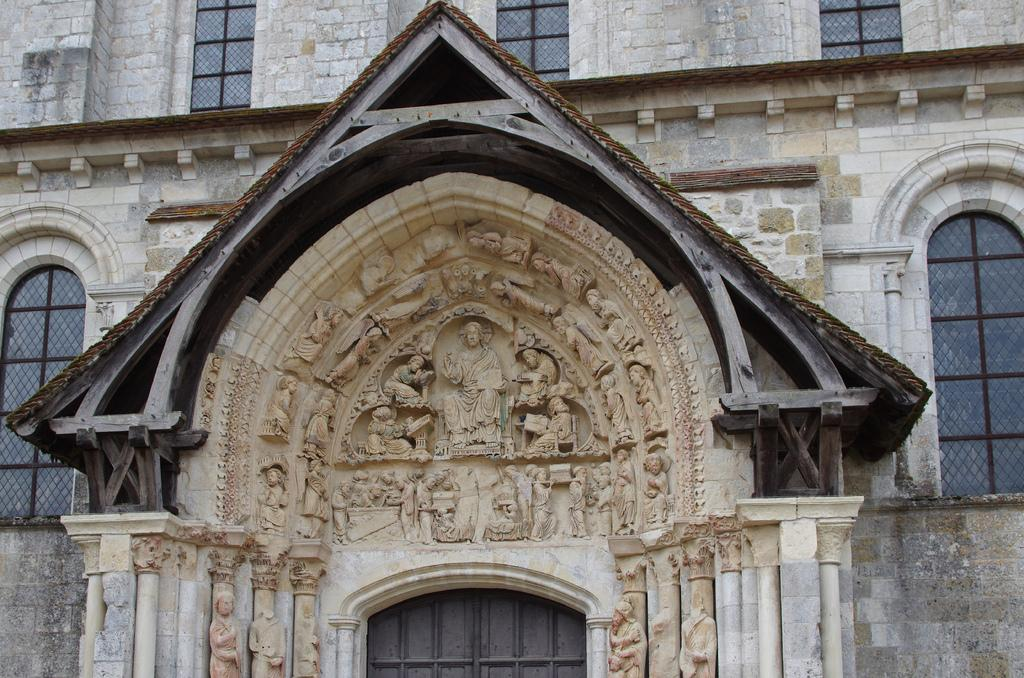What can be seen at the front of the image? There are sculptures in the front of the image. What type of structure is visible in the background? There is a building in the background of the image. Are there any openings in the structures visible in the image? Yes, there are windows visible in the image. How many weeks has the sculpture been on display in the image? The provided facts do not mention any information about the duration of the sculpture's display, so it cannot be determined from the image. Can you tell me who made the request for the sculpture to be placed in the image? There is no information about a request or the person who made it in the provided facts, so it cannot be determined from the image. 